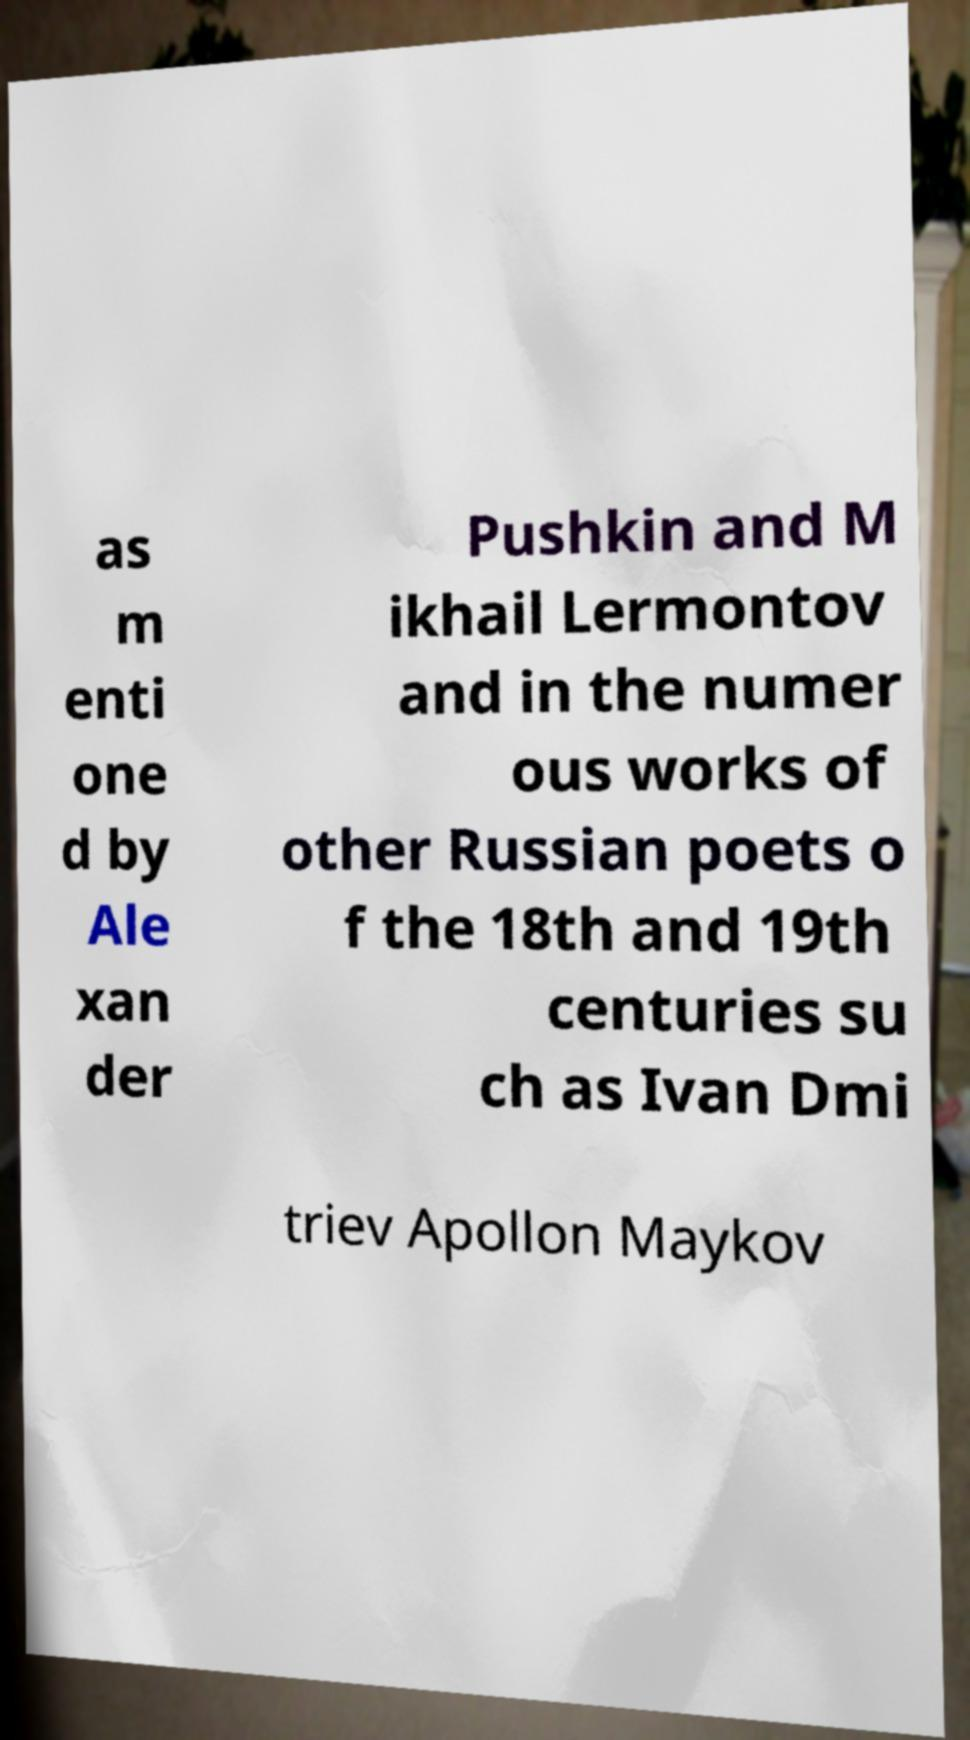I need the written content from this picture converted into text. Can you do that? as m enti one d by Ale xan der Pushkin and M ikhail Lermontov and in the numer ous works of other Russian poets o f the 18th and 19th centuries su ch as Ivan Dmi triev Apollon Maykov 